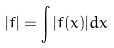Convert formula to latex. <formula><loc_0><loc_0><loc_500><loc_500>| f | = \int | f ( x ) | d x</formula> 